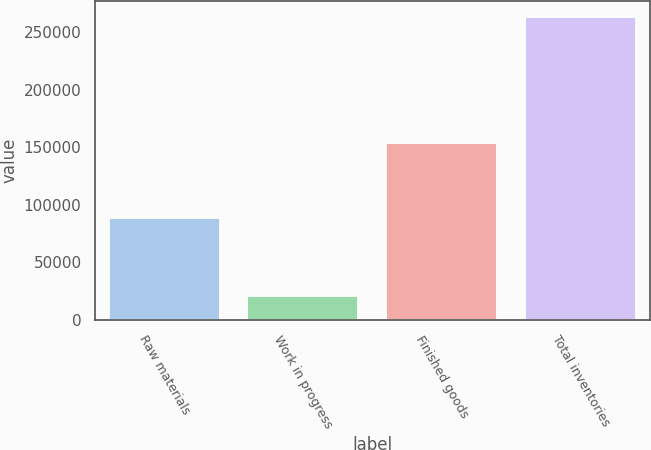Convert chart. <chart><loc_0><loc_0><loc_500><loc_500><bar_chart><fcel>Raw materials<fcel>Work in progress<fcel>Finished goods<fcel>Total inventories<nl><fcel>88625<fcel>20901<fcel>153889<fcel>263415<nl></chart> 